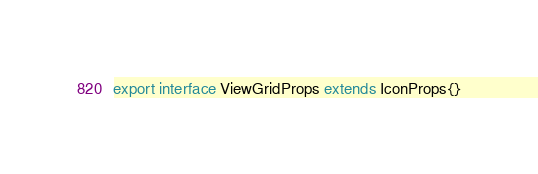Convert code to text. <code><loc_0><loc_0><loc_500><loc_500><_TypeScript_>
export interface ViewGridProps extends IconProps{}</code> 